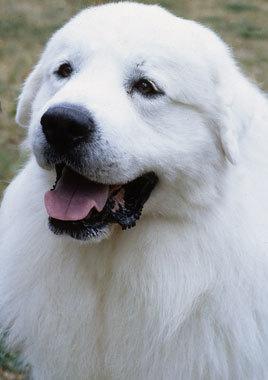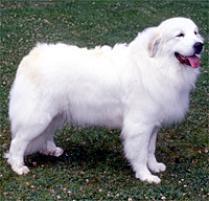The first image is the image on the left, the second image is the image on the right. For the images shown, is this caption "There is one dog facing right in the right image." true? Answer yes or no. Yes. The first image is the image on the left, the second image is the image on the right. Considering the images on both sides, is "At least one of the dogs has a collar and tag clearly visible around it's neck." valid? Answer yes or no. No. The first image is the image on the left, the second image is the image on the right. Analyze the images presented: Is the assertion "At least one dog is standing in the grass." valid? Answer yes or no. Yes. The first image is the image on the left, the second image is the image on the right. Assess this claim about the two images: "One image only shows the face and chest of a dog facing left.". Correct or not? Answer yes or no. Yes. The first image is the image on the left, the second image is the image on the right. Evaluate the accuracy of this statement regarding the images: "The dog in the right image is facing right.". Is it true? Answer yes or no. Yes. The first image is the image on the left, the second image is the image on the right. For the images displayed, is the sentence "An image shows one big white dog, standing with its head and body turned rightwards." factually correct? Answer yes or no. Yes. 